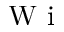<formula> <loc_0><loc_0><loc_500><loc_500>W i</formula> 